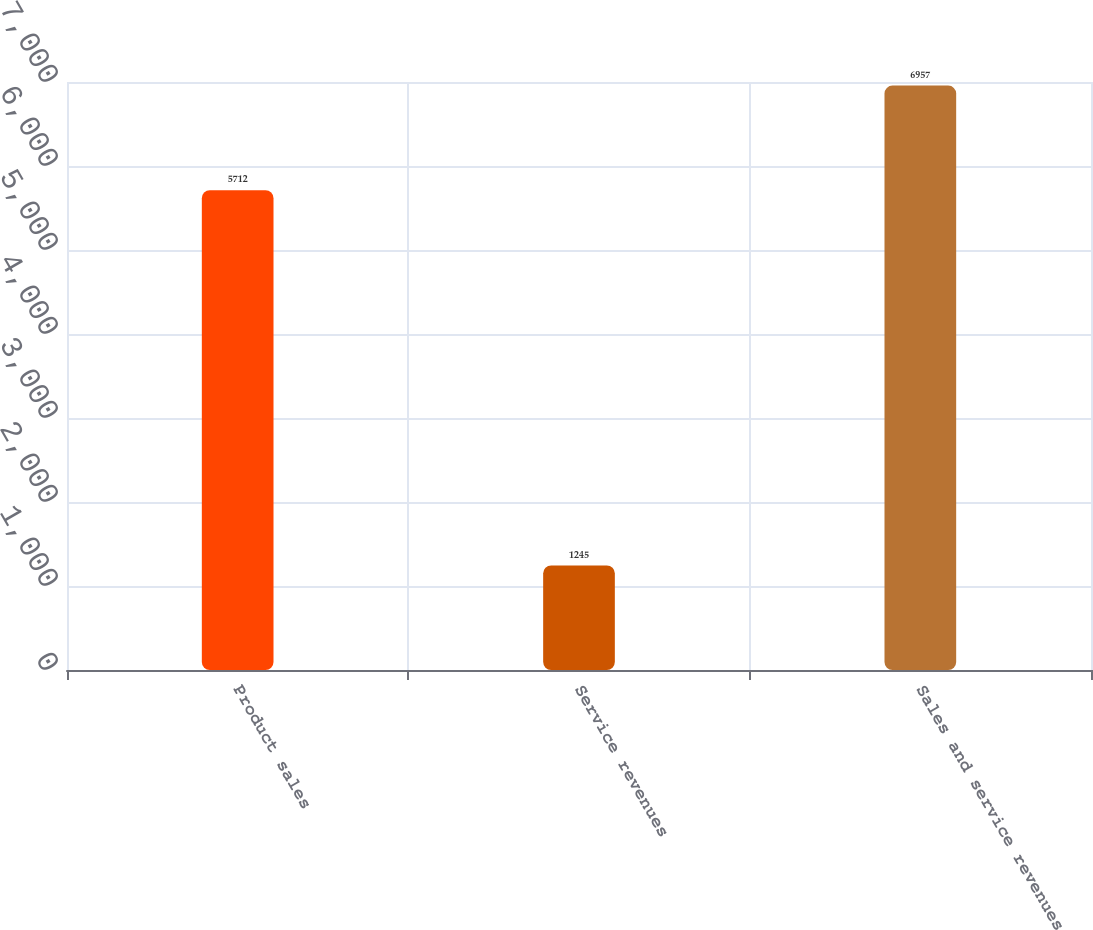Convert chart. <chart><loc_0><loc_0><loc_500><loc_500><bar_chart><fcel>Product sales<fcel>Service revenues<fcel>Sales and service revenues<nl><fcel>5712<fcel>1245<fcel>6957<nl></chart> 